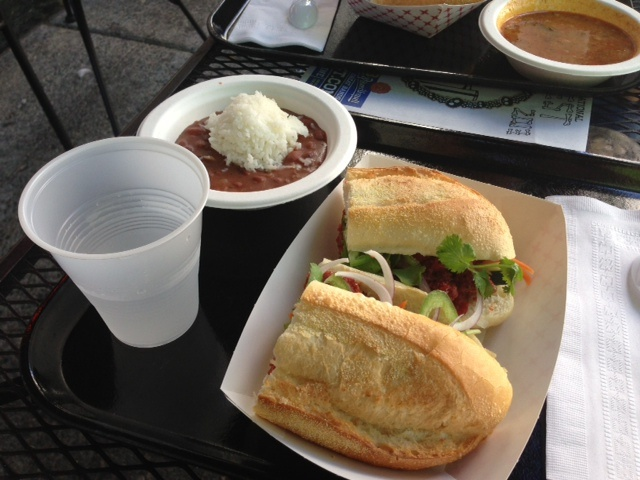Describe the objects in this image and their specific colors. I can see bowl in black, tan, and olive tones, sandwich in black, olive, and tan tones, cup in black, darkgray, lightgray, and gray tones, sandwich in black, tan, and olive tones, and bowl in black, ivory, darkgray, maroon, and gray tones in this image. 